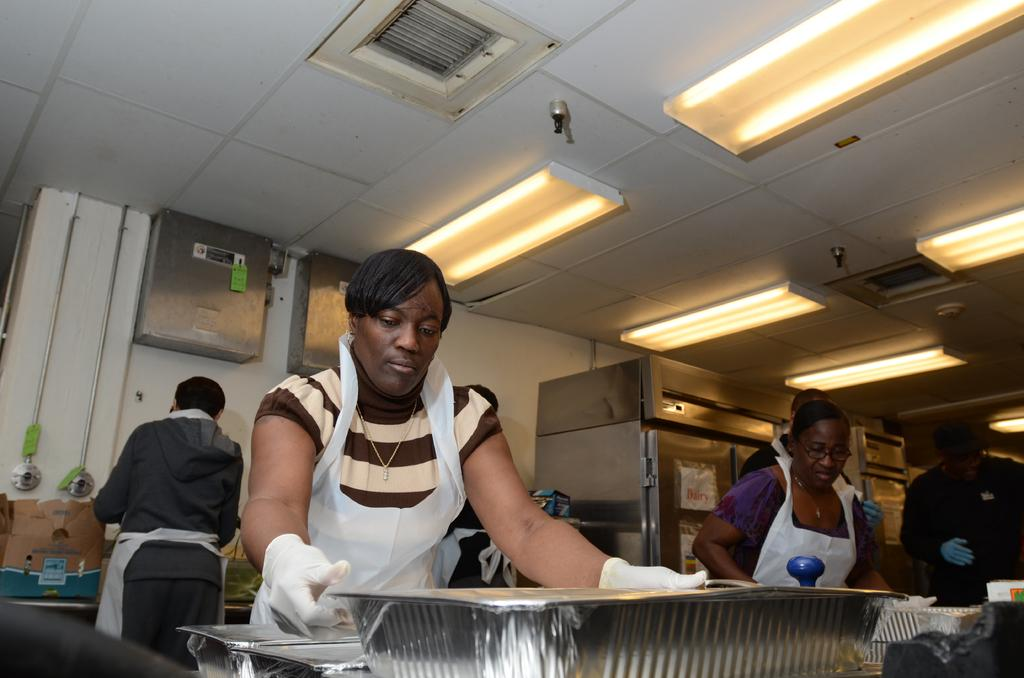How many people are present in the image? There are six persons standing in the image. What type of containers can be seen in the image? There are silver foil containers with lids in the image. What can be seen in the background of the image? There are lights and other objects visible in the background of the image. What time of day is it in the image, considering it's an afternoon scene? The provided facts do not mention the time of day or any afternoon scene, so it cannot be determined from the image. 